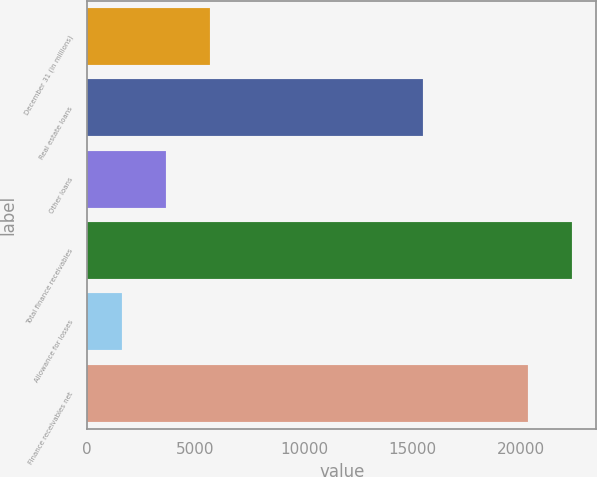Convert chart. <chart><loc_0><loc_0><loc_500><loc_500><bar_chart><fcel>December 31 (in millions)<fcel>Real estate loans<fcel>Other loans<fcel>Total finance receivables<fcel>Allowance for losses<fcel>Finance receivables net<nl><fcel>5671.4<fcel>15473<fcel>3638.7<fcel>22359.7<fcel>1606<fcel>20327<nl></chart> 